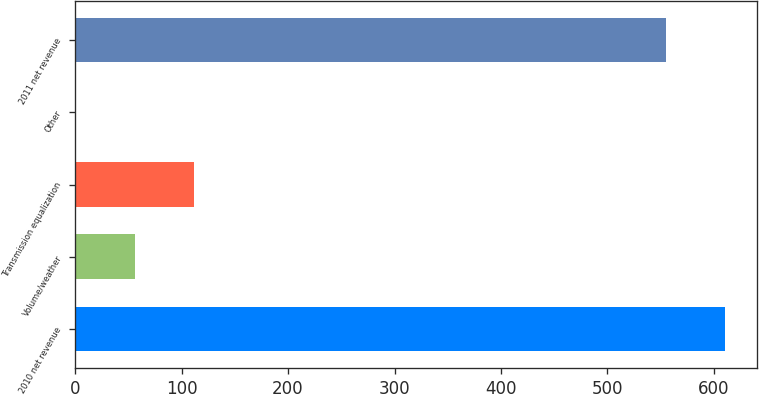<chart> <loc_0><loc_0><loc_500><loc_500><bar_chart><fcel>2010 net revenue<fcel>Volume/weather<fcel>Transmission equalization<fcel>Other<fcel>2011 net revenue<nl><fcel>610.39<fcel>55.89<fcel>111.38<fcel>0.4<fcel>554.9<nl></chart> 